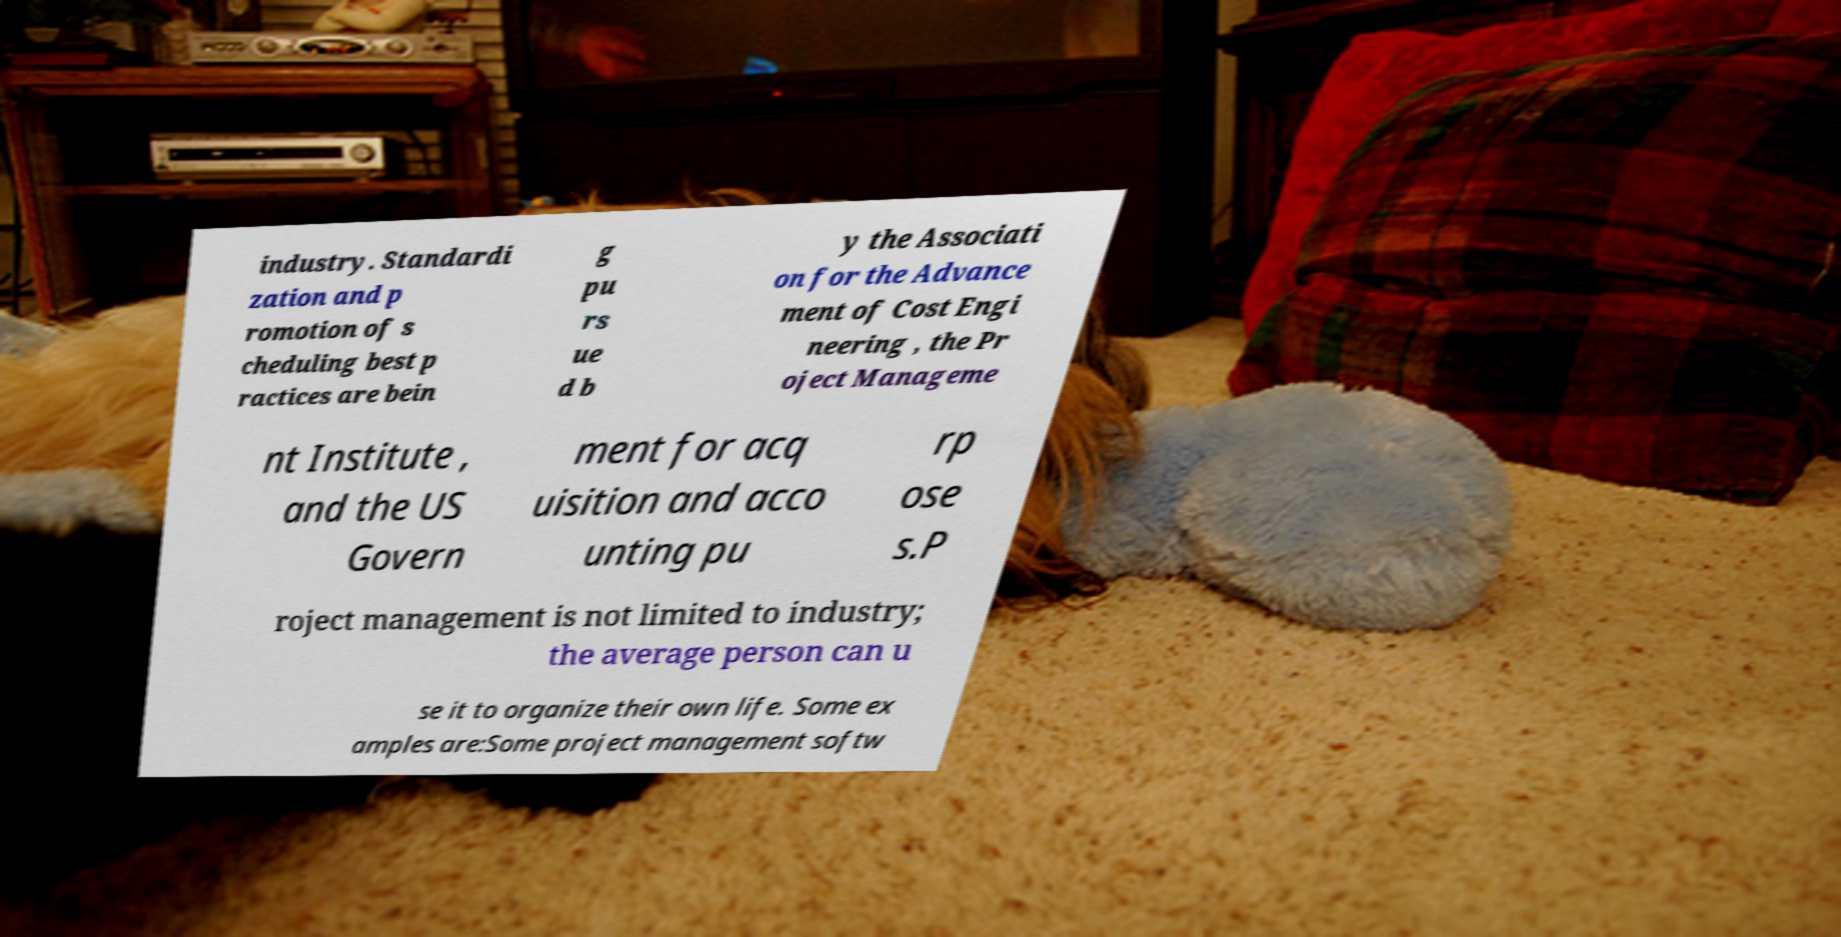What messages or text are displayed in this image? I need them in a readable, typed format. industry. Standardi zation and p romotion of s cheduling best p ractices are bein g pu rs ue d b y the Associati on for the Advance ment of Cost Engi neering , the Pr oject Manageme nt Institute , and the US Govern ment for acq uisition and acco unting pu rp ose s.P roject management is not limited to industry; the average person can u se it to organize their own life. Some ex amples are:Some project management softw 